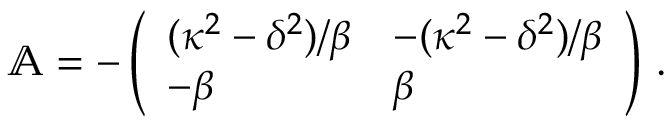Convert formula to latex. <formula><loc_0><loc_0><loc_500><loc_500>\begin{array} { r } { \mathbb { A } = - \left ( \begin{array} { l l } { ( { \kappa ^ { 2 } - \delta ^ { 2 } } ) / { \beta } } & { - ( { \kappa ^ { 2 } - \delta ^ { 2 } } ) / { \beta } } \\ { - \beta } & { \beta } \end{array} \right ) \, . } \end{array}</formula> 